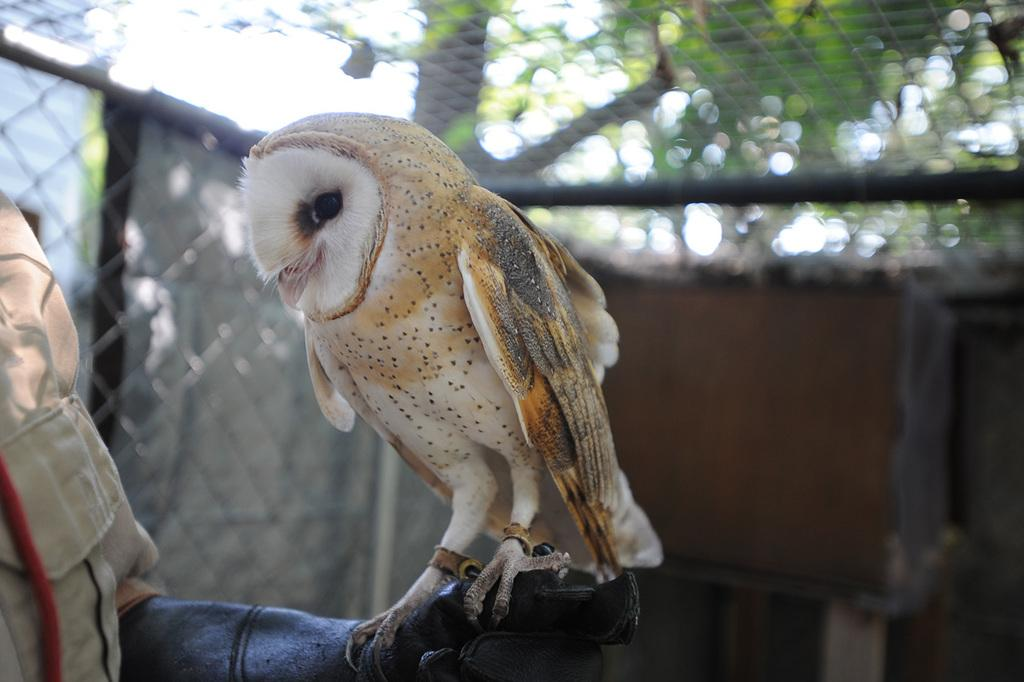What type of animal can be seen in the image? There is a bird in the image. Where is the bird located? The bird is on an object. What can be seen in the background of the image? There is a cage in the background of the image. How would you describe the background of the image? The background of the image is blurred. What type of teeth can be seen in the bird's throat in the image? There are no teeth visible in the bird's throat in the image, as birds do not have teeth. 